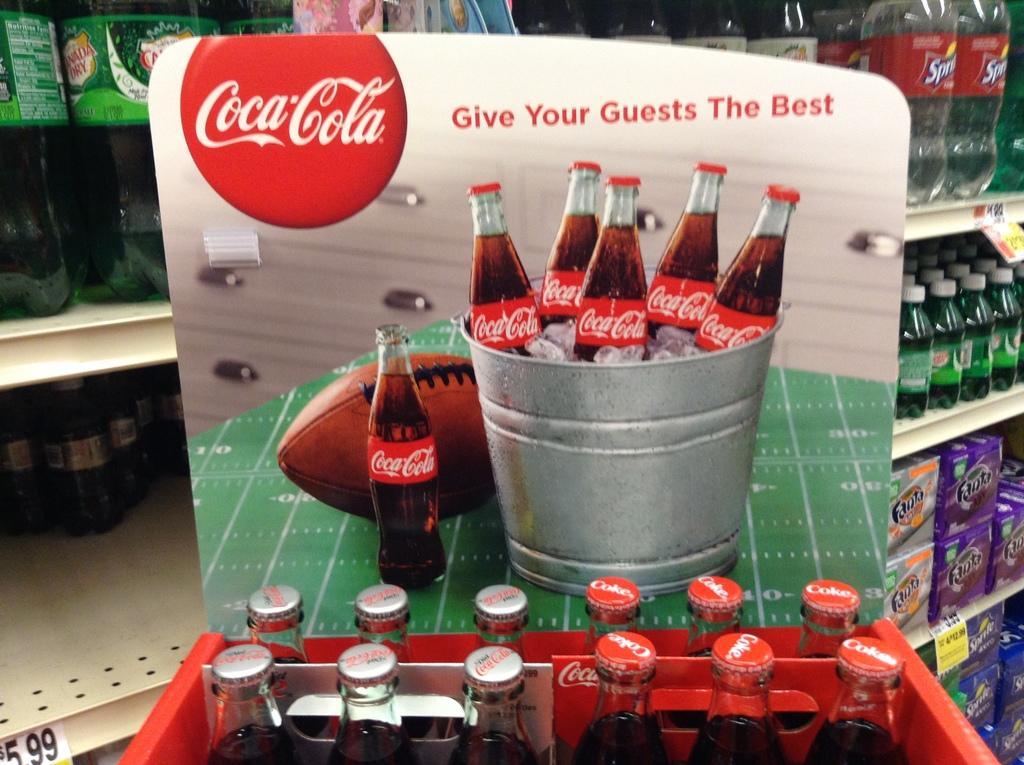Could you give a brief overview of what you see in this image? In this image i can see a couple of glass bottles in a tray. 